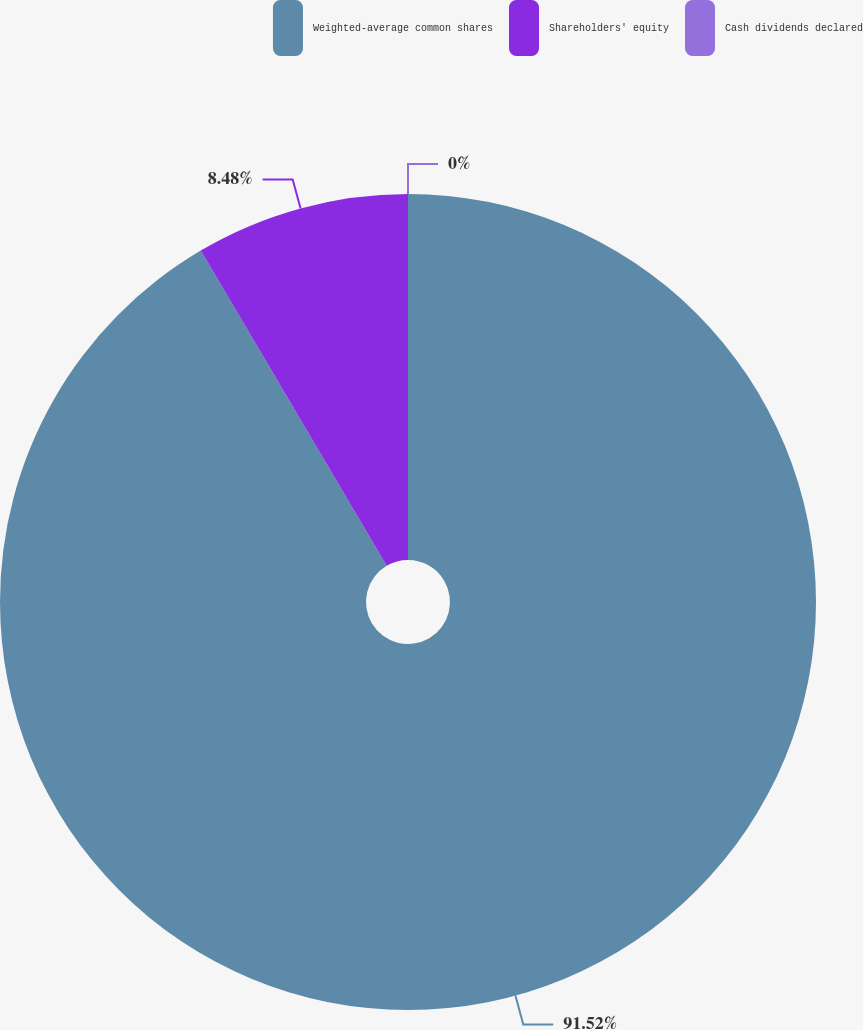Convert chart. <chart><loc_0><loc_0><loc_500><loc_500><pie_chart><fcel>Weighted-average common shares<fcel>Shareholders' equity<fcel>Cash dividends declared<nl><fcel>91.52%<fcel>8.48%<fcel>0.0%<nl></chart> 